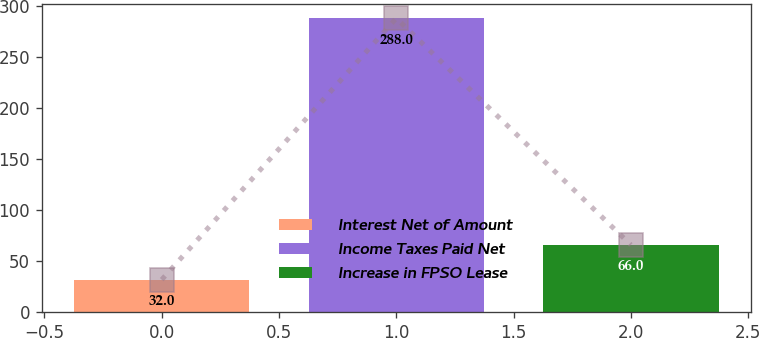<chart> <loc_0><loc_0><loc_500><loc_500><bar_chart><fcel>Interest Net of Amount<fcel>Income Taxes Paid Net<fcel>Increase in FPSO Lease<nl><fcel>32<fcel>288<fcel>66<nl></chart> 